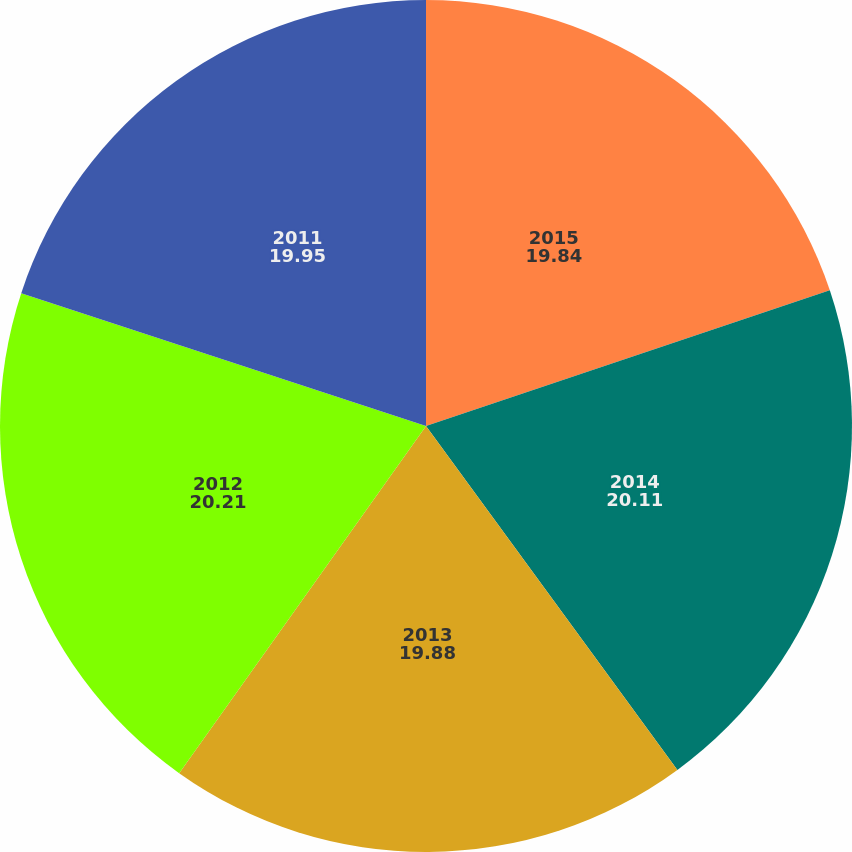<chart> <loc_0><loc_0><loc_500><loc_500><pie_chart><fcel>2015<fcel>2014<fcel>2013<fcel>2012<fcel>2011<nl><fcel>19.84%<fcel>20.11%<fcel>19.88%<fcel>20.21%<fcel>19.95%<nl></chart> 